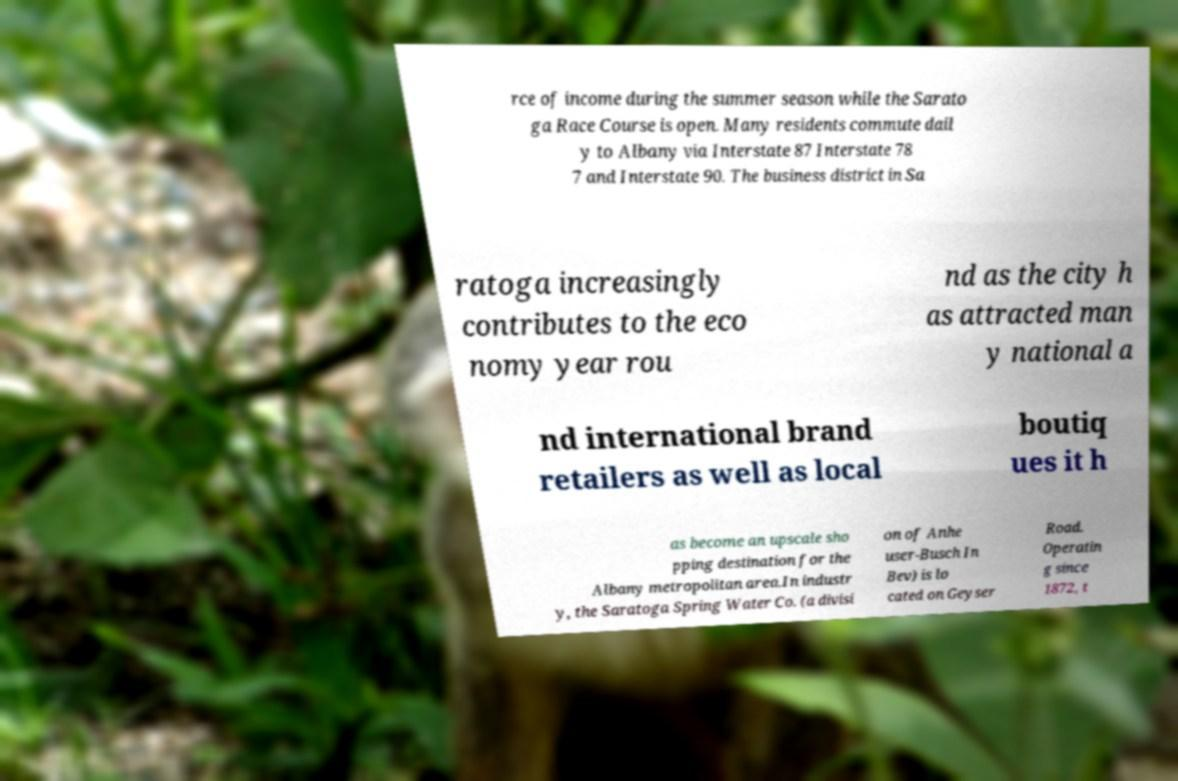Can you accurately transcribe the text from the provided image for me? rce of income during the summer season while the Sarato ga Race Course is open. Many residents commute dail y to Albany via Interstate 87 Interstate 78 7 and Interstate 90. The business district in Sa ratoga increasingly contributes to the eco nomy year rou nd as the city h as attracted man y national a nd international brand retailers as well as local boutiq ues it h as become an upscale sho pping destination for the Albany metropolitan area.In industr y, the Saratoga Spring Water Co. (a divisi on of Anhe user-Busch In Bev) is lo cated on Geyser Road. Operatin g since 1872, t 